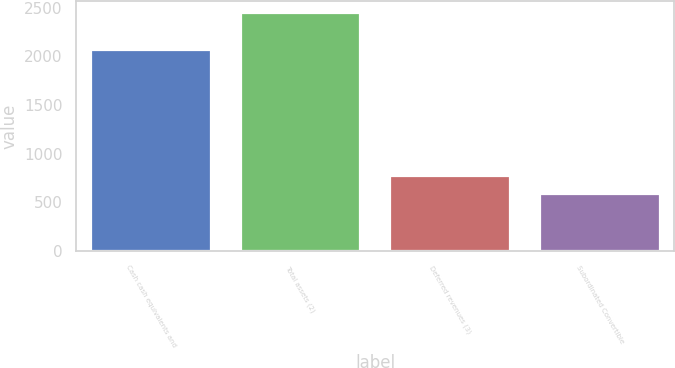<chart> <loc_0><loc_0><loc_500><loc_500><bar_chart><fcel>Cash cash equivalents and<fcel>Total assets (2)<fcel>Deferred revenues (3)<fcel>Subordinated Convertible<nl><fcel>2061<fcel>2444<fcel>768.2<fcel>582<nl></chart> 